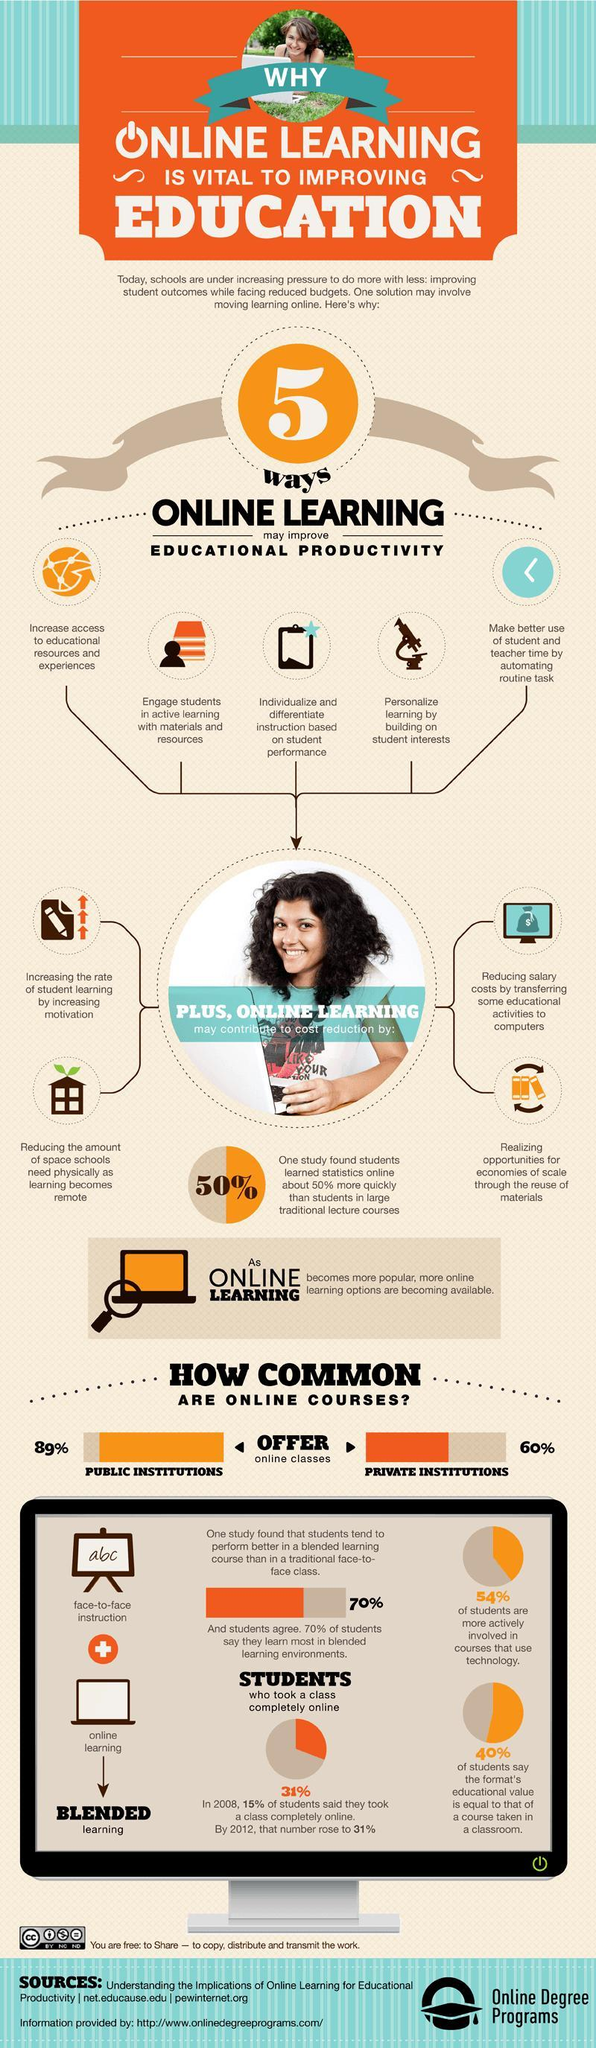What improvement does the microscope show
Answer the question with a short phrase. Personalize learning by building on students interests Blended learning is a combination of what face-to-face instructon, online learning How many type of cost reductions have been highlighted 4 What subject did students learn 50% more quickly online than with the traditional lecture courses statistics what is printed on the writing board abc What was the increase in the % of online students from 2008 to 2012 16 